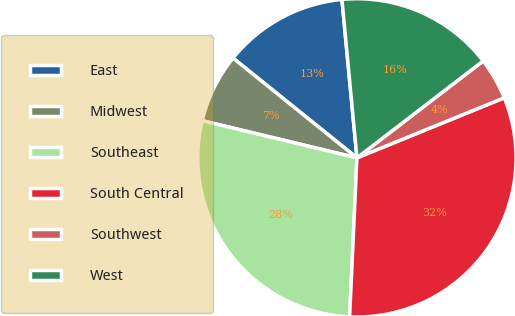<chart> <loc_0><loc_0><loc_500><loc_500><pie_chart><fcel>East<fcel>Midwest<fcel>Southeast<fcel>South Central<fcel>Southwest<fcel>West<nl><fcel>12.71%<fcel>7.03%<fcel>28.02%<fcel>31.89%<fcel>4.26%<fcel>16.08%<nl></chart> 